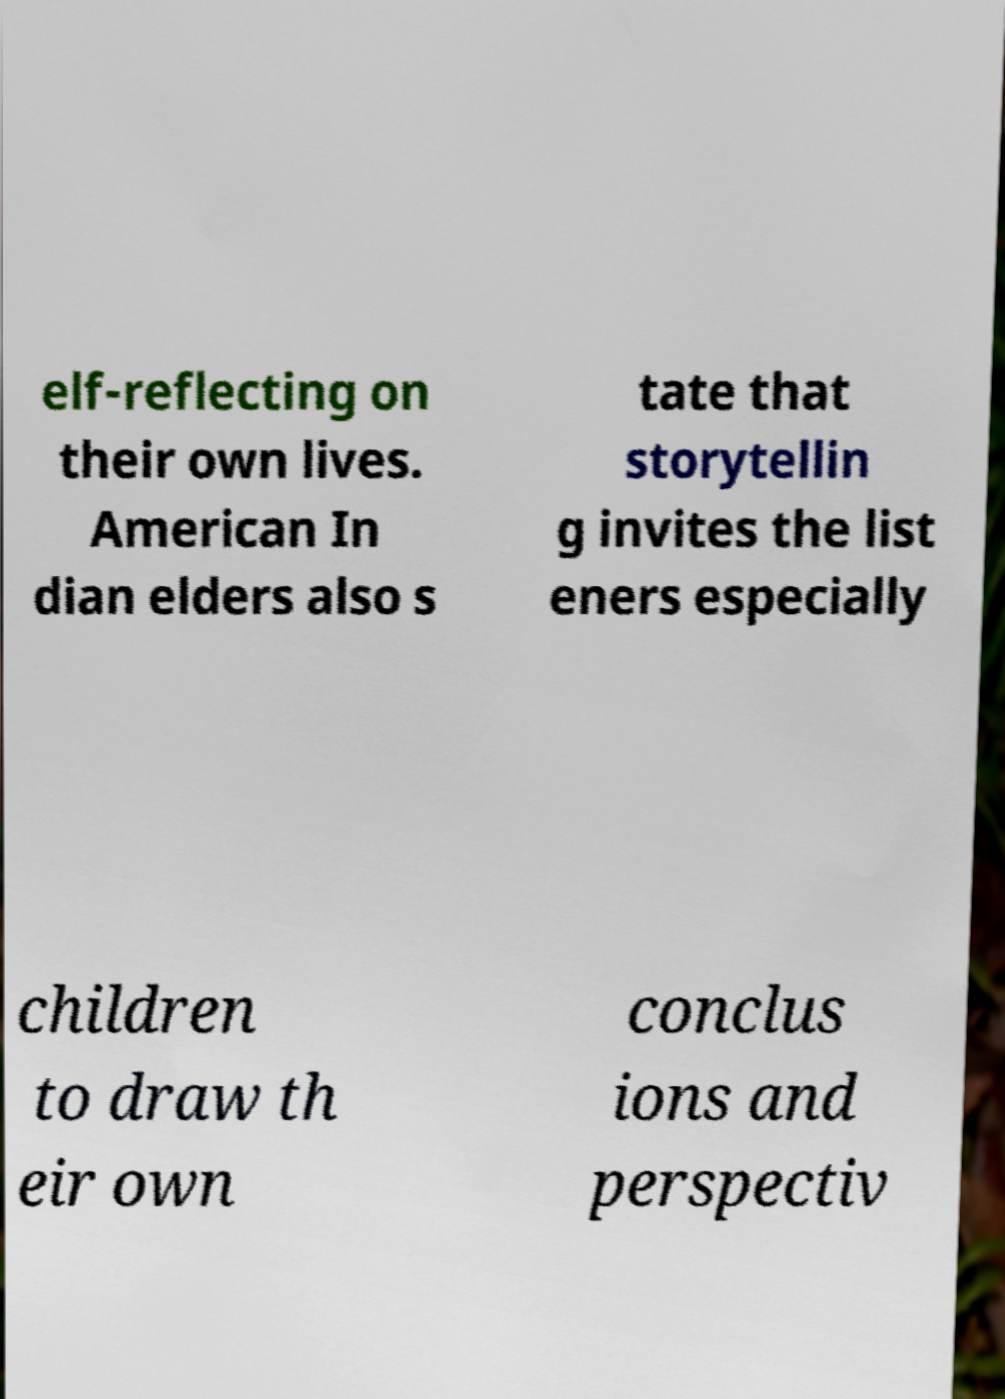What messages or text are displayed in this image? I need them in a readable, typed format. elf-reflecting on their own lives. American In dian elders also s tate that storytellin g invites the list eners especially children to draw th eir own conclus ions and perspectiv 